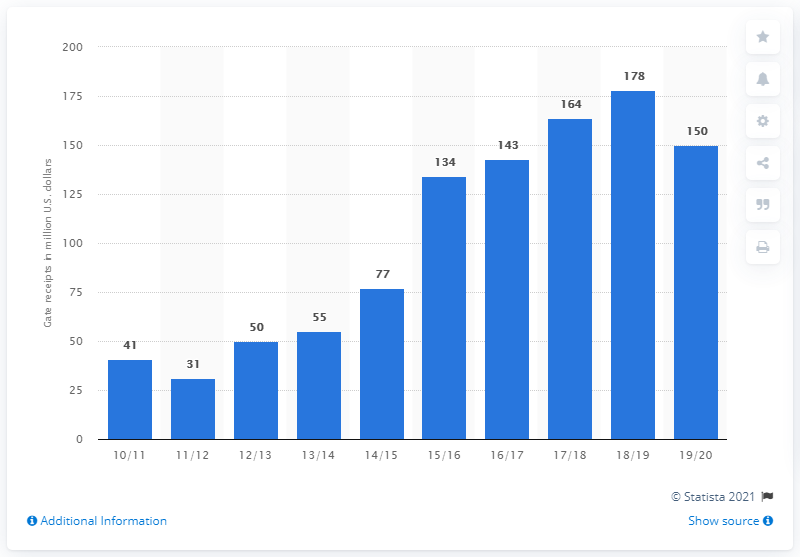Draw attention to some important aspects in this diagram. The gate receipts of the Golden State Warriors in the 2019/20 season were approximately 150 dollars. 